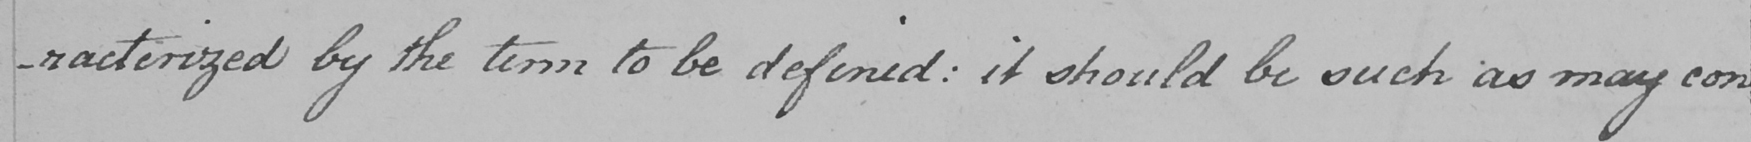Please provide the text content of this handwritten line. -racterized by the term to be defined :  it should be such as may con 